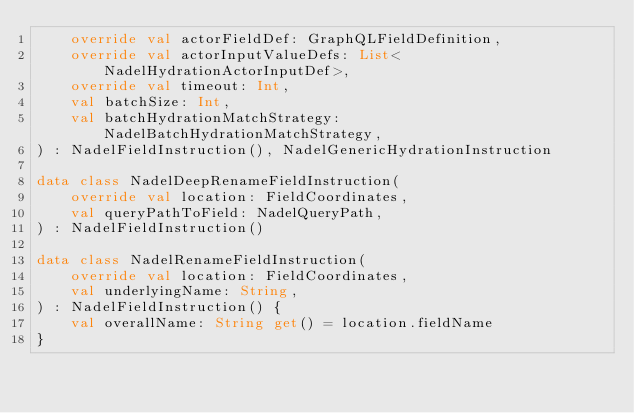Convert code to text. <code><loc_0><loc_0><loc_500><loc_500><_Kotlin_>    override val actorFieldDef: GraphQLFieldDefinition,
    override val actorInputValueDefs: List<NadelHydrationActorInputDef>,
    override val timeout: Int,
    val batchSize: Int,
    val batchHydrationMatchStrategy: NadelBatchHydrationMatchStrategy,
) : NadelFieldInstruction(), NadelGenericHydrationInstruction

data class NadelDeepRenameFieldInstruction(
    override val location: FieldCoordinates,
    val queryPathToField: NadelQueryPath,
) : NadelFieldInstruction()

data class NadelRenameFieldInstruction(
    override val location: FieldCoordinates,
    val underlyingName: String,
) : NadelFieldInstruction() {
    val overallName: String get() = location.fieldName
}
</code> 